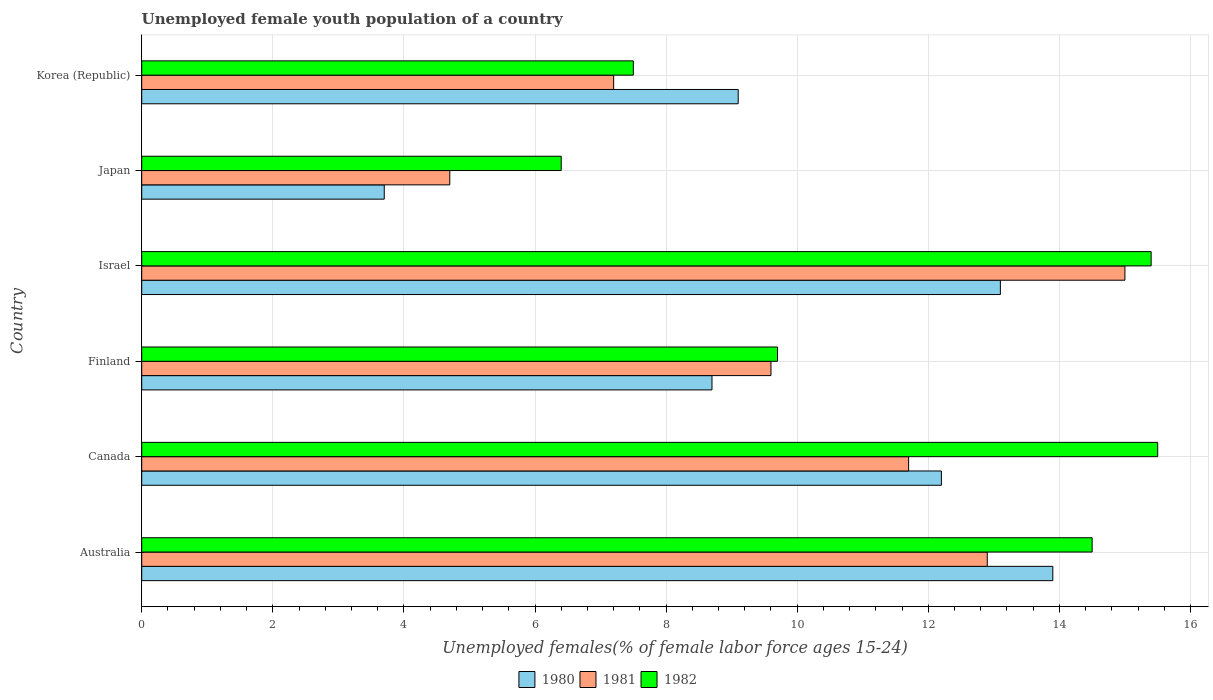How many different coloured bars are there?
Provide a succinct answer. 3. Are the number of bars on each tick of the Y-axis equal?
Provide a succinct answer. Yes. How many bars are there on the 2nd tick from the top?
Make the answer very short. 3. How many bars are there on the 1st tick from the bottom?
Ensure brevity in your answer.  3. What is the label of the 5th group of bars from the top?
Your response must be concise. Canada. What is the percentage of unemployed female youth population in 1982 in Korea (Republic)?
Keep it short and to the point. 7.5. Across all countries, what is the minimum percentage of unemployed female youth population in 1982?
Provide a short and direct response. 6.4. In which country was the percentage of unemployed female youth population in 1982 minimum?
Give a very brief answer. Japan. What is the total percentage of unemployed female youth population in 1980 in the graph?
Provide a succinct answer. 60.7. What is the difference between the percentage of unemployed female youth population in 1981 in Israel and that in Korea (Republic)?
Offer a terse response. 7.8. What is the difference between the percentage of unemployed female youth population in 1981 in Finland and the percentage of unemployed female youth population in 1982 in Korea (Republic)?
Provide a succinct answer. 2.1. What is the average percentage of unemployed female youth population in 1981 per country?
Give a very brief answer. 10.18. What is the difference between the percentage of unemployed female youth population in 1980 and percentage of unemployed female youth population in 1982 in Finland?
Offer a very short reply. -1. What is the ratio of the percentage of unemployed female youth population in 1982 in Finland to that in Israel?
Keep it short and to the point. 0.63. What is the difference between the highest and the second highest percentage of unemployed female youth population in 1980?
Your response must be concise. 0.8. What is the difference between the highest and the lowest percentage of unemployed female youth population in 1980?
Make the answer very short. 10.2. In how many countries, is the percentage of unemployed female youth population in 1982 greater than the average percentage of unemployed female youth population in 1982 taken over all countries?
Make the answer very short. 3. Is the sum of the percentage of unemployed female youth population in 1982 in Canada and Korea (Republic) greater than the maximum percentage of unemployed female youth population in 1981 across all countries?
Keep it short and to the point. Yes. Are all the bars in the graph horizontal?
Provide a short and direct response. Yes. How many countries are there in the graph?
Provide a succinct answer. 6. Does the graph contain grids?
Offer a terse response. Yes. How many legend labels are there?
Offer a terse response. 3. What is the title of the graph?
Offer a terse response. Unemployed female youth population of a country. What is the label or title of the X-axis?
Ensure brevity in your answer.  Unemployed females(% of female labor force ages 15-24). What is the label or title of the Y-axis?
Offer a very short reply. Country. What is the Unemployed females(% of female labor force ages 15-24) in 1980 in Australia?
Give a very brief answer. 13.9. What is the Unemployed females(% of female labor force ages 15-24) of 1981 in Australia?
Offer a very short reply. 12.9. What is the Unemployed females(% of female labor force ages 15-24) in 1982 in Australia?
Ensure brevity in your answer.  14.5. What is the Unemployed females(% of female labor force ages 15-24) in 1980 in Canada?
Your answer should be very brief. 12.2. What is the Unemployed females(% of female labor force ages 15-24) of 1981 in Canada?
Keep it short and to the point. 11.7. What is the Unemployed females(% of female labor force ages 15-24) in 1982 in Canada?
Your answer should be very brief. 15.5. What is the Unemployed females(% of female labor force ages 15-24) of 1980 in Finland?
Ensure brevity in your answer.  8.7. What is the Unemployed females(% of female labor force ages 15-24) in 1981 in Finland?
Make the answer very short. 9.6. What is the Unemployed females(% of female labor force ages 15-24) of 1982 in Finland?
Ensure brevity in your answer.  9.7. What is the Unemployed females(% of female labor force ages 15-24) in 1980 in Israel?
Provide a short and direct response. 13.1. What is the Unemployed females(% of female labor force ages 15-24) in 1982 in Israel?
Offer a very short reply. 15.4. What is the Unemployed females(% of female labor force ages 15-24) of 1980 in Japan?
Make the answer very short. 3.7. What is the Unemployed females(% of female labor force ages 15-24) in 1981 in Japan?
Provide a succinct answer. 4.7. What is the Unemployed females(% of female labor force ages 15-24) of 1982 in Japan?
Offer a terse response. 6.4. What is the Unemployed females(% of female labor force ages 15-24) of 1980 in Korea (Republic)?
Your answer should be very brief. 9.1. What is the Unemployed females(% of female labor force ages 15-24) of 1981 in Korea (Republic)?
Make the answer very short. 7.2. Across all countries, what is the maximum Unemployed females(% of female labor force ages 15-24) in 1980?
Provide a succinct answer. 13.9. Across all countries, what is the maximum Unemployed females(% of female labor force ages 15-24) in 1981?
Provide a short and direct response. 15. Across all countries, what is the minimum Unemployed females(% of female labor force ages 15-24) in 1980?
Your answer should be very brief. 3.7. Across all countries, what is the minimum Unemployed females(% of female labor force ages 15-24) of 1981?
Ensure brevity in your answer.  4.7. Across all countries, what is the minimum Unemployed females(% of female labor force ages 15-24) of 1982?
Provide a succinct answer. 6.4. What is the total Unemployed females(% of female labor force ages 15-24) of 1980 in the graph?
Your response must be concise. 60.7. What is the total Unemployed females(% of female labor force ages 15-24) in 1981 in the graph?
Your response must be concise. 61.1. What is the total Unemployed females(% of female labor force ages 15-24) in 1982 in the graph?
Provide a succinct answer. 69. What is the difference between the Unemployed females(% of female labor force ages 15-24) of 1980 in Australia and that in Canada?
Make the answer very short. 1.7. What is the difference between the Unemployed females(% of female labor force ages 15-24) of 1981 in Australia and that in Finland?
Provide a short and direct response. 3.3. What is the difference between the Unemployed females(% of female labor force ages 15-24) of 1980 in Australia and that in Israel?
Provide a succinct answer. 0.8. What is the difference between the Unemployed females(% of female labor force ages 15-24) in 1981 in Australia and that in Israel?
Your response must be concise. -2.1. What is the difference between the Unemployed females(% of female labor force ages 15-24) in 1981 in Australia and that in Korea (Republic)?
Your answer should be compact. 5.7. What is the difference between the Unemployed females(% of female labor force ages 15-24) in 1982 in Australia and that in Korea (Republic)?
Provide a succinct answer. 7. What is the difference between the Unemployed females(% of female labor force ages 15-24) of 1980 in Canada and that in Finland?
Your response must be concise. 3.5. What is the difference between the Unemployed females(% of female labor force ages 15-24) of 1980 in Canada and that in Israel?
Offer a terse response. -0.9. What is the difference between the Unemployed females(% of female labor force ages 15-24) in 1981 in Canada and that in Israel?
Provide a short and direct response. -3.3. What is the difference between the Unemployed females(% of female labor force ages 15-24) of 1980 in Canada and that in Japan?
Offer a very short reply. 8.5. What is the difference between the Unemployed females(% of female labor force ages 15-24) in 1981 in Canada and that in Korea (Republic)?
Provide a short and direct response. 4.5. What is the difference between the Unemployed females(% of female labor force ages 15-24) of 1982 in Canada and that in Korea (Republic)?
Keep it short and to the point. 8. What is the difference between the Unemployed females(% of female labor force ages 15-24) in 1981 in Finland and that in Israel?
Offer a very short reply. -5.4. What is the difference between the Unemployed females(% of female labor force ages 15-24) of 1982 in Finland and that in Israel?
Your answer should be compact. -5.7. What is the difference between the Unemployed females(% of female labor force ages 15-24) in 1980 in Finland and that in Japan?
Make the answer very short. 5. What is the difference between the Unemployed females(% of female labor force ages 15-24) of 1982 in Finland and that in Japan?
Offer a very short reply. 3.3. What is the difference between the Unemployed females(% of female labor force ages 15-24) in 1980 in Japan and that in Korea (Republic)?
Give a very brief answer. -5.4. What is the difference between the Unemployed females(% of female labor force ages 15-24) of 1982 in Japan and that in Korea (Republic)?
Make the answer very short. -1.1. What is the difference between the Unemployed females(% of female labor force ages 15-24) in 1980 in Australia and the Unemployed females(% of female labor force ages 15-24) in 1982 in Canada?
Give a very brief answer. -1.6. What is the difference between the Unemployed females(% of female labor force ages 15-24) of 1981 in Australia and the Unemployed females(% of female labor force ages 15-24) of 1982 in Canada?
Keep it short and to the point. -2.6. What is the difference between the Unemployed females(% of female labor force ages 15-24) of 1980 in Australia and the Unemployed females(% of female labor force ages 15-24) of 1982 in Finland?
Give a very brief answer. 4.2. What is the difference between the Unemployed females(% of female labor force ages 15-24) in 1980 in Australia and the Unemployed females(% of female labor force ages 15-24) in 1982 in Israel?
Keep it short and to the point. -1.5. What is the difference between the Unemployed females(% of female labor force ages 15-24) in 1981 in Australia and the Unemployed females(% of female labor force ages 15-24) in 1982 in Israel?
Offer a terse response. -2.5. What is the difference between the Unemployed females(% of female labor force ages 15-24) in 1980 in Australia and the Unemployed females(% of female labor force ages 15-24) in 1981 in Japan?
Provide a succinct answer. 9.2. What is the difference between the Unemployed females(% of female labor force ages 15-24) of 1980 in Australia and the Unemployed females(% of female labor force ages 15-24) of 1982 in Japan?
Offer a terse response. 7.5. What is the difference between the Unemployed females(% of female labor force ages 15-24) in 1981 in Australia and the Unemployed females(% of female labor force ages 15-24) in 1982 in Japan?
Ensure brevity in your answer.  6.5. What is the difference between the Unemployed females(% of female labor force ages 15-24) in 1980 in Australia and the Unemployed females(% of female labor force ages 15-24) in 1981 in Korea (Republic)?
Give a very brief answer. 6.7. What is the difference between the Unemployed females(% of female labor force ages 15-24) in 1980 in Australia and the Unemployed females(% of female labor force ages 15-24) in 1982 in Korea (Republic)?
Offer a very short reply. 6.4. What is the difference between the Unemployed females(% of female labor force ages 15-24) of 1981 in Australia and the Unemployed females(% of female labor force ages 15-24) of 1982 in Korea (Republic)?
Give a very brief answer. 5.4. What is the difference between the Unemployed females(% of female labor force ages 15-24) of 1980 in Canada and the Unemployed females(% of female labor force ages 15-24) of 1982 in Finland?
Your answer should be very brief. 2.5. What is the difference between the Unemployed females(% of female labor force ages 15-24) of 1980 in Canada and the Unemployed females(% of female labor force ages 15-24) of 1981 in Israel?
Ensure brevity in your answer.  -2.8. What is the difference between the Unemployed females(% of female labor force ages 15-24) of 1980 in Canada and the Unemployed females(% of female labor force ages 15-24) of 1982 in Israel?
Make the answer very short. -3.2. What is the difference between the Unemployed females(% of female labor force ages 15-24) of 1981 in Canada and the Unemployed females(% of female labor force ages 15-24) of 1982 in Israel?
Offer a terse response. -3.7. What is the difference between the Unemployed females(% of female labor force ages 15-24) of 1980 in Canada and the Unemployed females(% of female labor force ages 15-24) of 1981 in Japan?
Provide a short and direct response. 7.5. What is the difference between the Unemployed females(% of female labor force ages 15-24) of 1980 in Canada and the Unemployed females(% of female labor force ages 15-24) of 1981 in Korea (Republic)?
Make the answer very short. 5. What is the difference between the Unemployed females(% of female labor force ages 15-24) of 1981 in Finland and the Unemployed females(% of female labor force ages 15-24) of 1982 in Israel?
Your answer should be very brief. -5.8. What is the difference between the Unemployed females(% of female labor force ages 15-24) of 1980 in Finland and the Unemployed females(% of female labor force ages 15-24) of 1981 in Japan?
Provide a short and direct response. 4. What is the difference between the Unemployed females(% of female labor force ages 15-24) in 1980 in Finland and the Unemployed females(% of female labor force ages 15-24) in 1982 in Japan?
Ensure brevity in your answer.  2.3. What is the difference between the Unemployed females(% of female labor force ages 15-24) in 1980 in Israel and the Unemployed females(% of female labor force ages 15-24) in 1981 in Japan?
Offer a very short reply. 8.4. What is the difference between the Unemployed females(% of female labor force ages 15-24) of 1981 in Israel and the Unemployed females(% of female labor force ages 15-24) of 1982 in Japan?
Keep it short and to the point. 8.6. What is the average Unemployed females(% of female labor force ages 15-24) of 1980 per country?
Ensure brevity in your answer.  10.12. What is the average Unemployed females(% of female labor force ages 15-24) of 1981 per country?
Give a very brief answer. 10.18. What is the difference between the Unemployed females(% of female labor force ages 15-24) in 1980 and Unemployed females(% of female labor force ages 15-24) in 1981 in Australia?
Ensure brevity in your answer.  1. What is the difference between the Unemployed females(% of female labor force ages 15-24) in 1980 and Unemployed females(% of female labor force ages 15-24) in 1982 in Australia?
Keep it short and to the point. -0.6. What is the difference between the Unemployed females(% of female labor force ages 15-24) in 1981 and Unemployed females(% of female labor force ages 15-24) in 1982 in Australia?
Ensure brevity in your answer.  -1.6. What is the difference between the Unemployed females(% of female labor force ages 15-24) of 1980 and Unemployed females(% of female labor force ages 15-24) of 1982 in Canada?
Offer a very short reply. -3.3. What is the difference between the Unemployed females(% of female labor force ages 15-24) in 1980 and Unemployed females(% of female labor force ages 15-24) in 1981 in Finland?
Provide a short and direct response. -0.9. What is the difference between the Unemployed females(% of female labor force ages 15-24) of 1980 and Unemployed females(% of female labor force ages 15-24) of 1982 in Finland?
Offer a terse response. -1. What is the difference between the Unemployed females(% of female labor force ages 15-24) of 1981 and Unemployed females(% of female labor force ages 15-24) of 1982 in Finland?
Your answer should be very brief. -0.1. What is the difference between the Unemployed females(% of female labor force ages 15-24) in 1980 and Unemployed females(% of female labor force ages 15-24) in 1981 in Israel?
Keep it short and to the point. -1.9. What is the difference between the Unemployed females(% of female labor force ages 15-24) of 1980 and Unemployed females(% of female labor force ages 15-24) of 1982 in Israel?
Keep it short and to the point. -2.3. What is the difference between the Unemployed females(% of female labor force ages 15-24) in 1981 and Unemployed females(% of female labor force ages 15-24) in 1982 in Israel?
Make the answer very short. -0.4. What is the difference between the Unemployed females(% of female labor force ages 15-24) of 1980 and Unemployed females(% of female labor force ages 15-24) of 1981 in Japan?
Offer a very short reply. -1. What is the difference between the Unemployed females(% of female labor force ages 15-24) in 1980 and Unemployed females(% of female labor force ages 15-24) in 1981 in Korea (Republic)?
Ensure brevity in your answer.  1.9. What is the ratio of the Unemployed females(% of female labor force ages 15-24) in 1980 in Australia to that in Canada?
Provide a succinct answer. 1.14. What is the ratio of the Unemployed females(% of female labor force ages 15-24) of 1981 in Australia to that in Canada?
Offer a terse response. 1.1. What is the ratio of the Unemployed females(% of female labor force ages 15-24) in 1982 in Australia to that in Canada?
Your response must be concise. 0.94. What is the ratio of the Unemployed females(% of female labor force ages 15-24) in 1980 in Australia to that in Finland?
Your response must be concise. 1.6. What is the ratio of the Unemployed females(% of female labor force ages 15-24) in 1981 in Australia to that in Finland?
Give a very brief answer. 1.34. What is the ratio of the Unemployed females(% of female labor force ages 15-24) of 1982 in Australia to that in Finland?
Provide a succinct answer. 1.49. What is the ratio of the Unemployed females(% of female labor force ages 15-24) in 1980 in Australia to that in Israel?
Provide a short and direct response. 1.06. What is the ratio of the Unemployed females(% of female labor force ages 15-24) in 1981 in Australia to that in Israel?
Ensure brevity in your answer.  0.86. What is the ratio of the Unemployed females(% of female labor force ages 15-24) in 1982 in Australia to that in Israel?
Provide a short and direct response. 0.94. What is the ratio of the Unemployed females(% of female labor force ages 15-24) in 1980 in Australia to that in Japan?
Your response must be concise. 3.76. What is the ratio of the Unemployed females(% of female labor force ages 15-24) in 1981 in Australia to that in Japan?
Offer a very short reply. 2.74. What is the ratio of the Unemployed females(% of female labor force ages 15-24) in 1982 in Australia to that in Japan?
Make the answer very short. 2.27. What is the ratio of the Unemployed females(% of female labor force ages 15-24) in 1980 in Australia to that in Korea (Republic)?
Provide a succinct answer. 1.53. What is the ratio of the Unemployed females(% of female labor force ages 15-24) of 1981 in Australia to that in Korea (Republic)?
Your answer should be very brief. 1.79. What is the ratio of the Unemployed females(% of female labor force ages 15-24) in 1982 in Australia to that in Korea (Republic)?
Make the answer very short. 1.93. What is the ratio of the Unemployed females(% of female labor force ages 15-24) of 1980 in Canada to that in Finland?
Your answer should be very brief. 1.4. What is the ratio of the Unemployed females(% of female labor force ages 15-24) in 1981 in Canada to that in Finland?
Your answer should be compact. 1.22. What is the ratio of the Unemployed females(% of female labor force ages 15-24) of 1982 in Canada to that in Finland?
Offer a terse response. 1.6. What is the ratio of the Unemployed females(% of female labor force ages 15-24) of 1980 in Canada to that in Israel?
Provide a succinct answer. 0.93. What is the ratio of the Unemployed females(% of female labor force ages 15-24) in 1981 in Canada to that in Israel?
Provide a short and direct response. 0.78. What is the ratio of the Unemployed females(% of female labor force ages 15-24) of 1982 in Canada to that in Israel?
Offer a terse response. 1.01. What is the ratio of the Unemployed females(% of female labor force ages 15-24) in 1980 in Canada to that in Japan?
Ensure brevity in your answer.  3.3. What is the ratio of the Unemployed females(% of female labor force ages 15-24) in 1981 in Canada to that in Japan?
Ensure brevity in your answer.  2.49. What is the ratio of the Unemployed females(% of female labor force ages 15-24) of 1982 in Canada to that in Japan?
Your answer should be compact. 2.42. What is the ratio of the Unemployed females(% of female labor force ages 15-24) in 1980 in Canada to that in Korea (Republic)?
Keep it short and to the point. 1.34. What is the ratio of the Unemployed females(% of female labor force ages 15-24) of 1981 in Canada to that in Korea (Republic)?
Keep it short and to the point. 1.62. What is the ratio of the Unemployed females(% of female labor force ages 15-24) in 1982 in Canada to that in Korea (Republic)?
Your answer should be compact. 2.07. What is the ratio of the Unemployed females(% of female labor force ages 15-24) in 1980 in Finland to that in Israel?
Make the answer very short. 0.66. What is the ratio of the Unemployed females(% of female labor force ages 15-24) in 1981 in Finland to that in Israel?
Offer a terse response. 0.64. What is the ratio of the Unemployed females(% of female labor force ages 15-24) of 1982 in Finland to that in Israel?
Offer a very short reply. 0.63. What is the ratio of the Unemployed females(% of female labor force ages 15-24) of 1980 in Finland to that in Japan?
Your answer should be compact. 2.35. What is the ratio of the Unemployed females(% of female labor force ages 15-24) of 1981 in Finland to that in Japan?
Offer a very short reply. 2.04. What is the ratio of the Unemployed females(% of female labor force ages 15-24) of 1982 in Finland to that in Japan?
Ensure brevity in your answer.  1.52. What is the ratio of the Unemployed females(% of female labor force ages 15-24) in 1980 in Finland to that in Korea (Republic)?
Offer a terse response. 0.96. What is the ratio of the Unemployed females(% of female labor force ages 15-24) in 1981 in Finland to that in Korea (Republic)?
Provide a short and direct response. 1.33. What is the ratio of the Unemployed females(% of female labor force ages 15-24) of 1982 in Finland to that in Korea (Republic)?
Offer a very short reply. 1.29. What is the ratio of the Unemployed females(% of female labor force ages 15-24) in 1980 in Israel to that in Japan?
Your answer should be compact. 3.54. What is the ratio of the Unemployed females(% of female labor force ages 15-24) in 1981 in Israel to that in Japan?
Keep it short and to the point. 3.19. What is the ratio of the Unemployed females(% of female labor force ages 15-24) of 1982 in Israel to that in Japan?
Provide a succinct answer. 2.41. What is the ratio of the Unemployed females(% of female labor force ages 15-24) in 1980 in Israel to that in Korea (Republic)?
Ensure brevity in your answer.  1.44. What is the ratio of the Unemployed females(% of female labor force ages 15-24) in 1981 in Israel to that in Korea (Republic)?
Offer a terse response. 2.08. What is the ratio of the Unemployed females(% of female labor force ages 15-24) in 1982 in Israel to that in Korea (Republic)?
Make the answer very short. 2.05. What is the ratio of the Unemployed females(% of female labor force ages 15-24) of 1980 in Japan to that in Korea (Republic)?
Keep it short and to the point. 0.41. What is the ratio of the Unemployed females(% of female labor force ages 15-24) in 1981 in Japan to that in Korea (Republic)?
Give a very brief answer. 0.65. What is the ratio of the Unemployed females(% of female labor force ages 15-24) in 1982 in Japan to that in Korea (Republic)?
Your answer should be very brief. 0.85. What is the difference between the highest and the second highest Unemployed females(% of female labor force ages 15-24) in 1981?
Your response must be concise. 2.1. What is the difference between the highest and the second highest Unemployed females(% of female labor force ages 15-24) in 1982?
Keep it short and to the point. 0.1. What is the difference between the highest and the lowest Unemployed females(% of female labor force ages 15-24) of 1980?
Your answer should be compact. 10.2. What is the difference between the highest and the lowest Unemployed females(% of female labor force ages 15-24) of 1982?
Offer a terse response. 9.1. 